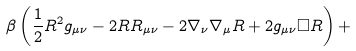Convert formula to latex. <formula><loc_0><loc_0><loc_500><loc_500>\beta \left ( { \frac { 1 } { 2 } } R ^ { 2 } g _ { \mu \nu } - 2 R R _ { \mu \nu } - 2 \nabla _ { \nu } \nabla _ { \mu } R + 2 g _ { \mu \nu } \Box R \right ) +</formula> 